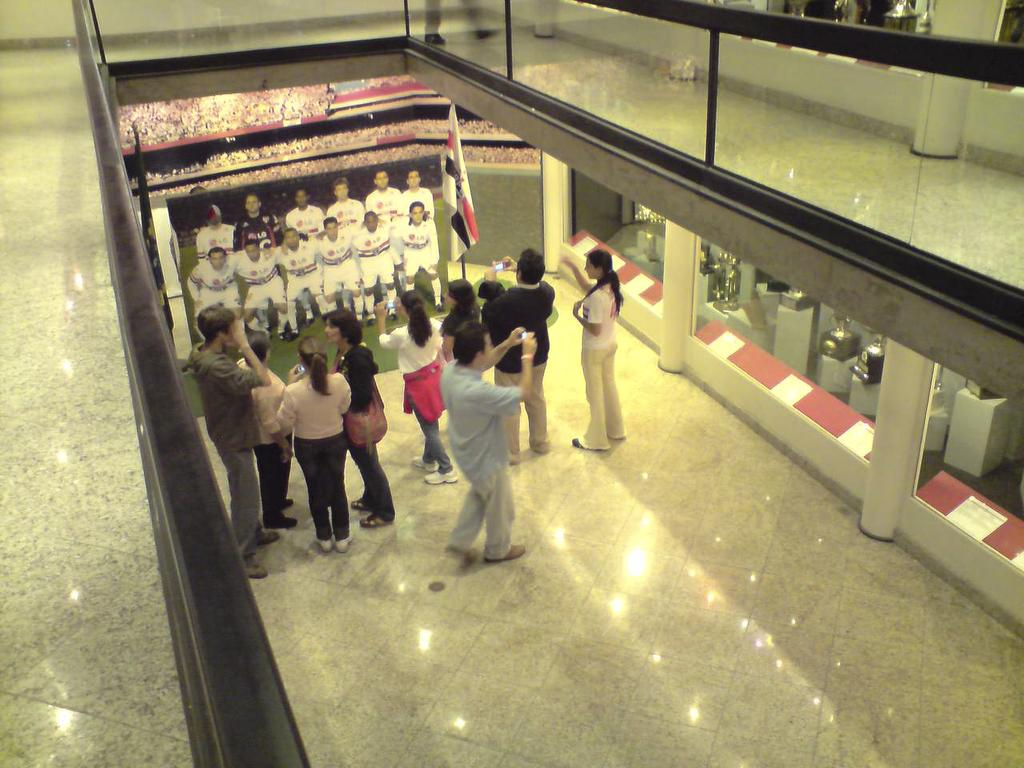How many people are in the image? There are people in the image, but the exact number is not specified. What are the people doing in the image? The people are standing on the floor and holding cameras in their hands. What is located behind the people in the image? In the background of the image, there are railings, trophies, and pillars. What might the people be doing with their cameras? The people might be taking pictures of the photograph they are standing in front of. How many babies are crawling on the floor in the image? There is no mention of babies in the image, so we cannot determine their presence or number. What direction are the people pointing their cameras in the image? The facts do not specify the direction in which the people are pointing their cameras, so we cannot answer this question definitively. 